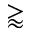Convert formula to latex. <formula><loc_0><loc_0><loc_500><loc_500>\gtrapprox</formula> 